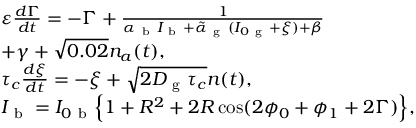Convert formula to latex. <formula><loc_0><loc_0><loc_500><loc_500>\begin{array} { l } { \varepsilon \frac { d \Gamma } { d t } = - \Gamma + \frac { 1 } { \alpha _ { b } I _ { b } + \tilde { \alpha } _ { g } ( I _ { 0 g } + \xi ) + \beta } } \\ { + \gamma + \sqrt { 0 . 0 2 } n _ { a } ( t ) , } \\ { \tau _ { c } \frac { d \xi } { d t } = - \xi + \sqrt { 2 D _ { g } \tau _ { c } } n ( t ) , } \\ { I _ { b } = I _ { 0 b } \left \{ 1 + R ^ { 2 } + 2 R \cos ( 2 \phi _ { 0 } + \phi _ { 1 } + 2 \Gamma ) \right \} , } \end{array}</formula> 